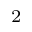<formula> <loc_0><loc_0><loc_500><loc_500>^ { 2 }</formula> 